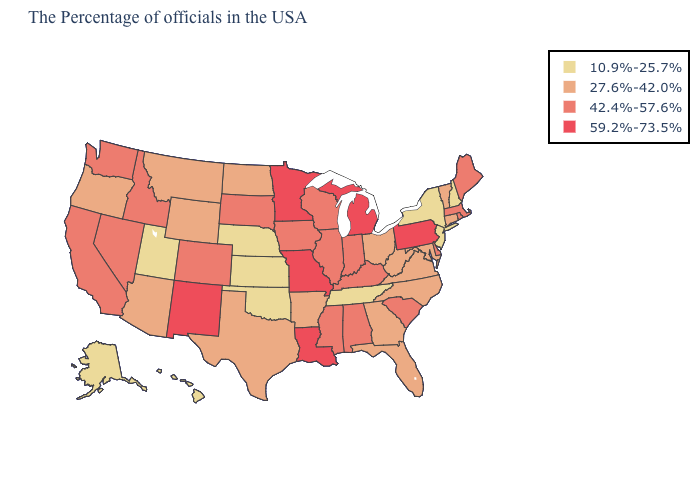Name the states that have a value in the range 10.9%-25.7%?
Be succinct. New Hampshire, New York, New Jersey, Tennessee, Kansas, Nebraska, Oklahoma, Utah, Alaska, Hawaii. What is the value of Nevada?
Keep it brief. 42.4%-57.6%. What is the value of Hawaii?
Give a very brief answer. 10.9%-25.7%. Name the states that have a value in the range 27.6%-42.0%?
Short answer required. Vermont, Connecticut, Maryland, Virginia, North Carolina, West Virginia, Ohio, Florida, Georgia, Arkansas, Texas, North Dakota, Wyoming, Montana, Arizona, Oregon. Does South Carolina have a lower value than Louisiana?
Short answer required. Yes. Among the states that border Ohio , does Indiana have the lowest value?
Concise answer only. No. Does Missouri have a higher value than Washington?
Short answer required. Yes. Name the states that have a value in the range 27.6%-42.0%?
Concise answer only. Vermont, Connecticut, Maryland, Virginia, North Carolina, West Virginia, Ohio, Florida, Georgia, Arkansas, Texas, North Dakota, Wyoming, Montana, Arizona, Oregon. Which states have the lowest value in the USA?
Write a very short answer. New Hampshire, New York, New Jersey, Tennessee, Kansas, Nebraska, Oklahoma, Utah, Alaska, Hawaii. What is the highest value in the MidWest ?
Keep it brief. 59.2%-73.5%. Is the legend a continuous bar?
Keep it brief. No. Among the states that border West Virginia , does Maryland have the highest value?
Keep it brief. No. Does Kansas have the lowest value in the MidWest?
Short answer required. Yes. What is the value of Nebraska?
Answer briefly. 10.9%-25.7%. Name the states that have a value in the range 59.2%-73.5%?
Be succinct. Pennsylvania, Michigan, Louisiana, Missouri, Minnesota, New Mexico. 